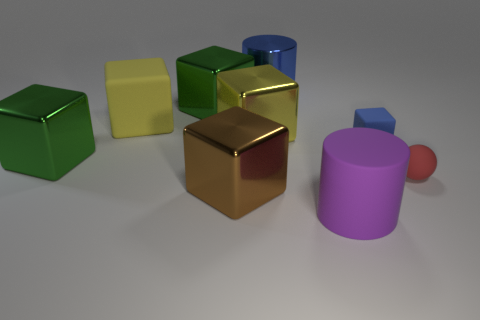Is the color of the large shiny cylinder the same as the tiny cube?
Provide a succinct answer. Yes. What material is the small thing that is the same color as the metallic cylinder?
Your answer should be very brief. Rubber. What shape is the tiny blue object that is made of the same material as the small sphere?
Offer a very short reply. Cube. What size is the cylinder that is in front of the brown thing in front of the yellow rubber thing?
Your answer should be very brief. Large. What number of tiny objects are blue rubber blocks or red rubber cylinders?
Ensure brevity in your answer.  1. How many other things are the same color as the big shiny cylinder?
Give a very brief answer. 1. There is a matte block that is left of the purple rubber thing; is its size the same as the rubber object in front of the small red sphere?
Keep it short and to the point. Yes. Are the brown cube and the blue thing that is right of the blue metallic object made of the same material?
Make the answer very short. No. Are there more brown shiny cubes right of the small red sphere than shiny objects that are in front of the large purple cylinder?
Provide a succinct answer. No. What is the color of the block that is on the right side of the cylinder in front of the large blue metal object?
Provide a succinct answer. Blue. 